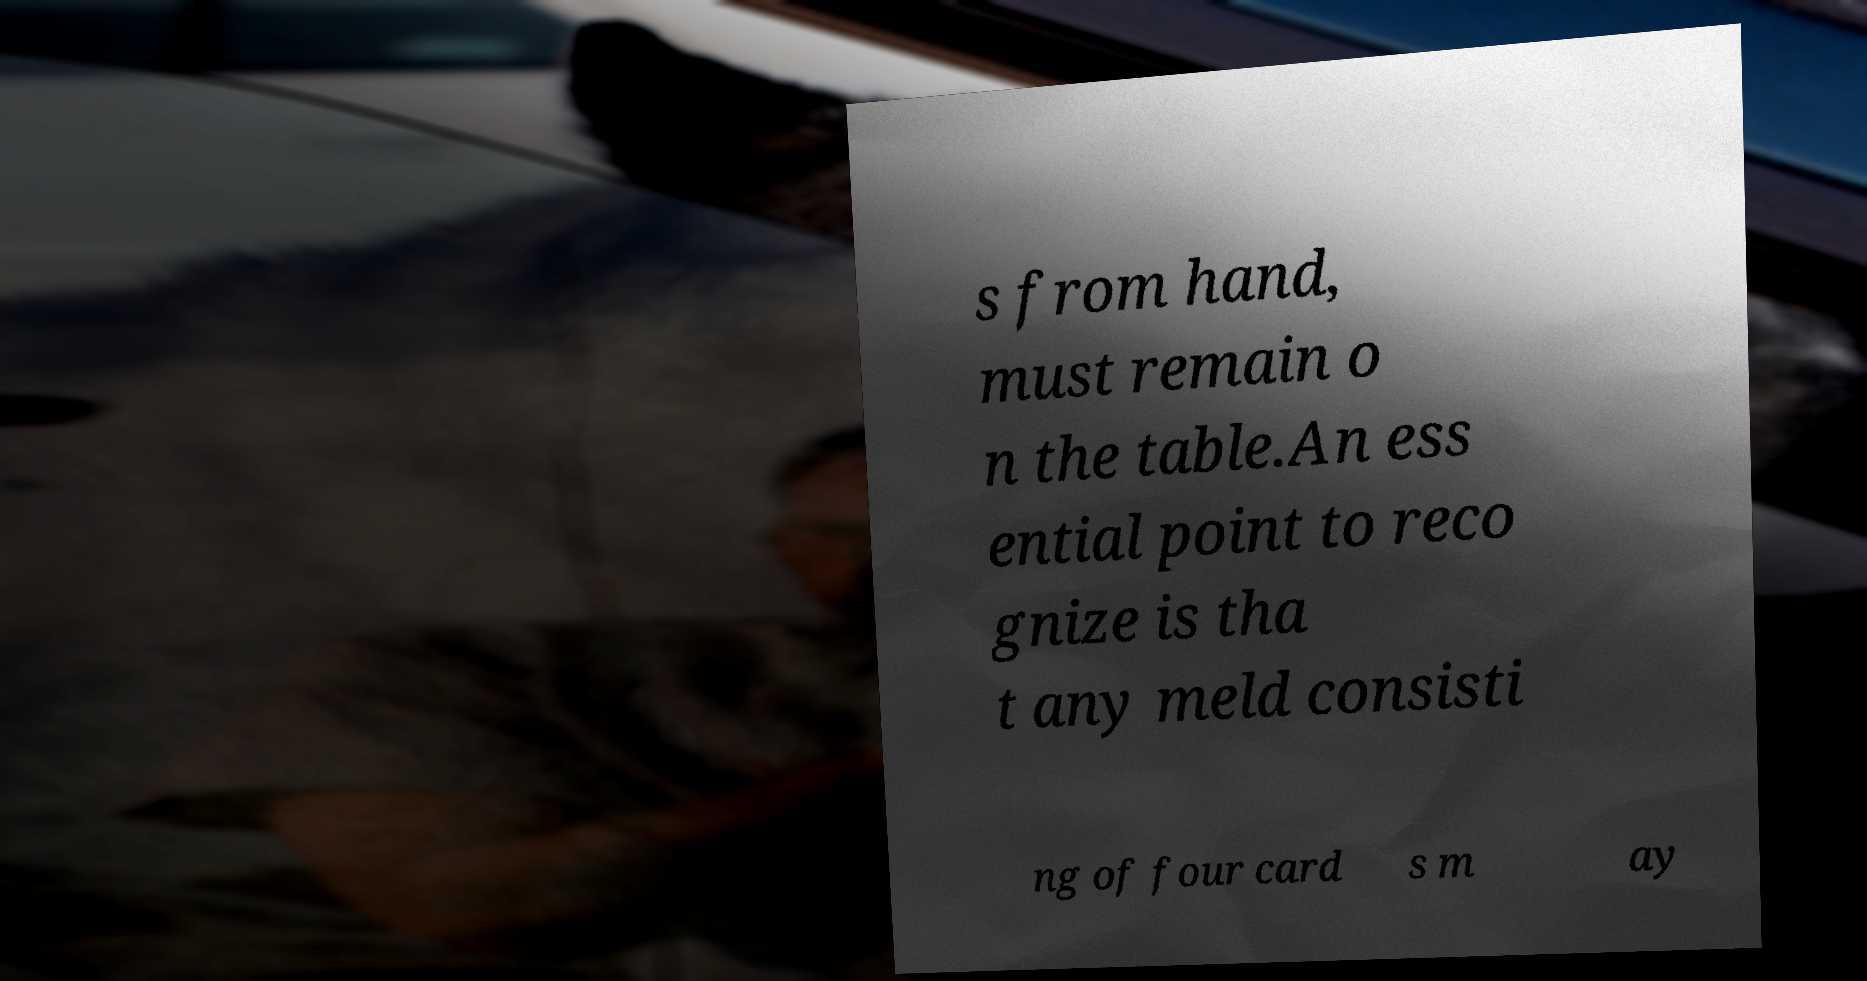Can you accurately transcribe the text from the provided image for me? s from hand, must remain o n the table.An ess ential point to reco gnize is tha t any meld consisti ng of four card s m ay 